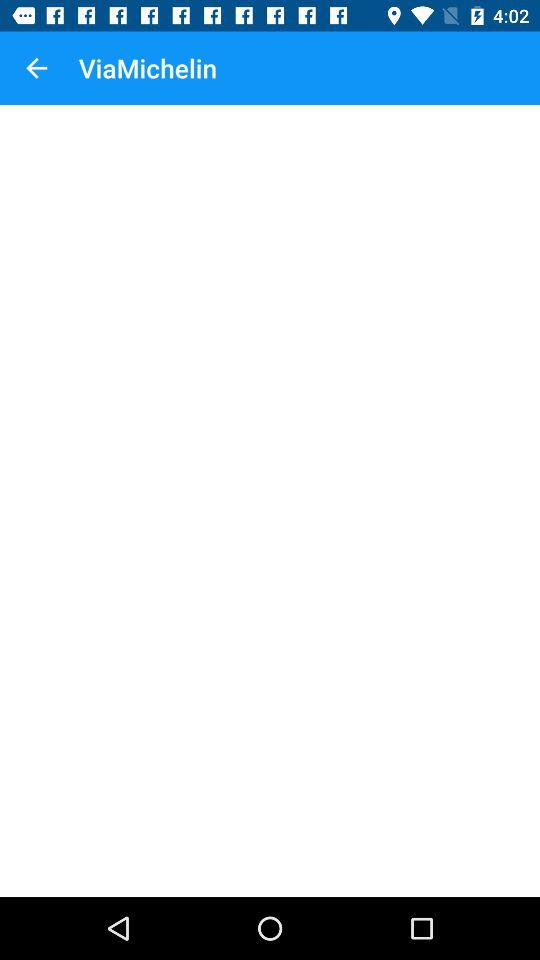What is the application name? The application name is "ViaMichelin". 